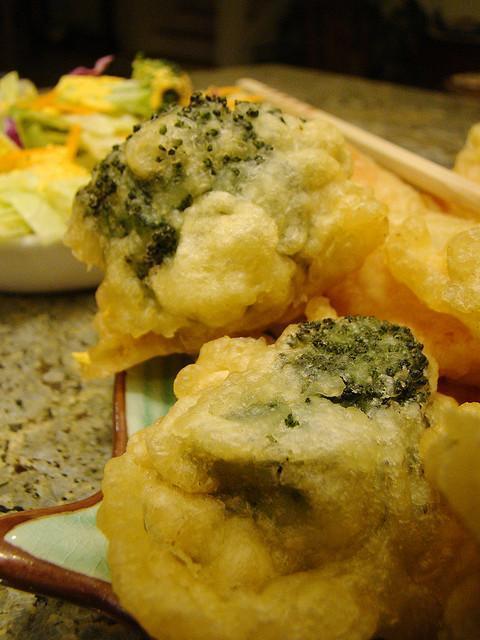How many knives are there?
Give a very brief answer. 0. How many broccolis can be seen?
Give a very brief answer. 2. 